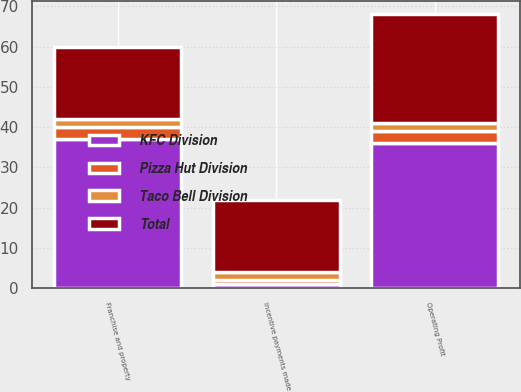Convert chart to OTSL. <chart><loc_0><loc_0><loc_500><loc_500><stacked_bar_chart><ecel><fcel>Incentive payments made<fcel>Franchise and property<fcel>Operating Profit<nl><fcel>KFC Division<fcel>1<fcel>37<fcel>36<nl><fcel>Taco Bell Division<fcel>2<fcel>2<fcel>2<nl><fcel>Pizza Hut Division<fcel>1<fcel>3<fcel>3<nl><fcel>Total<fcel>18<fcel>18<fcel>27<nl></chart> 